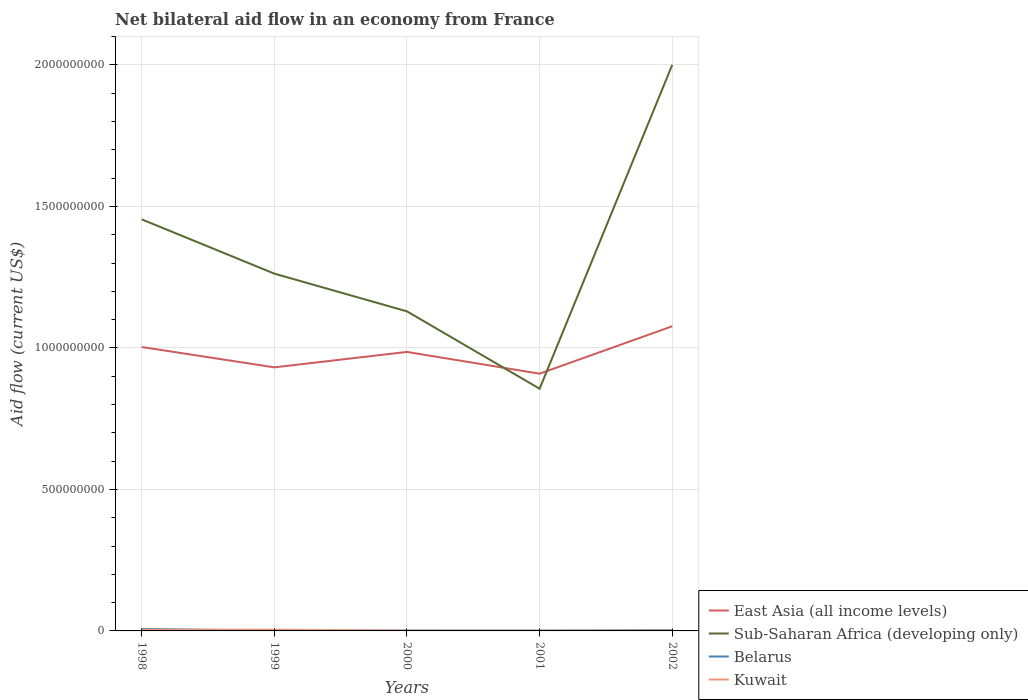Is the number of lines equal to the number of legend labels?
Your answer should be very brief. Yes. Across all years, what is the maximum net bilateral aid flow in Kuwait?
Offer a very short reply. 1.01e+06. What is the total net bilateral aid flow in East Asia (all income levels) in the graph?
Give a very brief answer. -7.34e+07. What is the difference between the highest and the second highest net bilateral aid flow in Sub-Saharan Africa (developing only)?
Your response must be concise. 1.14e+09. What is the difference between the highest and the lowest net bilateral aid flow in Kuwait?
Your answer should be compact. 2. How many years are there in the graph?
Your answer should be compact. 5. Are the values on the major ticks of Y-axis written in scientific E-notation?
Your answer should be very brief. No. Does the graph contain grids?
Ensure brevity in your answer.  Yes. How many legend labels are there?
Offer a terse response. 4. How are the legend labels stacked?
Provide a succinct answer. Vertical. What is the title of the graph?
Ensure brevity in your answer.  Net bilateral aid flow in an economy from France. Does "Upper middle income" appear as one of the legend labels in the graph?
Offer a very short reply. No. What is the label or title of the X-axis?
Keep it short and to the point. Years. What is the label or title of the Y-axis?
Your response must be concise. Aid flow (current US$). What is the Aid flow (current US$) of East Asia (all income levels) in 1998?
Your response must be concise. 1.00e+09. What is the Aid flow (current US$) of Sub-Saharan Africa (developing only) in 1998?
Make the answer very short. 1.45e+09. What is the Aid flow (current US$) of Belarus in 1998?
Provide a short and direct response. 6.89e+06. What is the Aid flow (current US$) of Kuwait in 1998?
Make the answer very short. 3.95e+06. What is the Aid flow (current US$) of East Asia (all income levels) in 1999?
Your answer should be compact. 9.31e+08. What is the Aid flow (current US$) of Sub-Saharan Africa (developing only) in 1999?
Give a very brief answer. 1.26e+09. What is the Aid flow (current US$) of Belarus in 1999?
Provide a short and direct response. 1.30e+06. What is the Aid flow (current US$) in Kuwait in 1999?
Provide a succinct answer. 4.50e+06. What is the Aid flow (current US$) of East Asia (all income levels) in 2000?
Provide a short and direct response. 9.86e+08. What is the Aid flow (current US$) of Sub-Saharan Africa (developing only) in 2000?
Make the answer very short. 1.13e+09. What is the Aid flow (current US$) of Belarus in 2000?
Give a very brief answer. 1.20e+06. What is the Aid flow (current US$) of Kuwait in 2000?
Give a very brief answer. 1.04e+06. What is the Aid flow (current US$) in East Asia (all income levels) in 2001?
Give a very brief answer. 9.09e+08. What is the Aid flow (current US$) in Sub-Saharan Africa (developing only) in 2001?
Provide a short and direct response. 8.56e+08. What is the Aid flow (current US$) of Belarus in 2001?
Offer a terse response. 1.13e+06. What is the Aid flow (current US$) of Kuwait in 2001?
Give a very brief answer. 1.01e+06. What is the Aid flow (current US$) in East Asia (all income levels) in 2002?
Make the answer very short. 1.08e+09. What is the Aid flow (current US$) of Sub-Saharan Africa (developing only) in 2002?
Ensure brevity in your answer.  2.00e+09. What is the Aid flow (current US$) of Belarus in 2002?
Ensure brevity in your answer.  2.82e+06. What is the Aid flow (current US$) of Kuwait in 2002?
Provide a short and direct response. 1.40e+06. Across all years, what is the maximum Aid flow (current US$) of East Asia (all income levels)?
Keep it short and to the point. 1.08e+09. Across all years, what is the maximum Aid flow (current US$) in Sub-Saharan Africa (developing only)?
Provide a succinct answer. 2.00e+09. Across all years, what is the maximum Aid flow (current US$) of Belarus?
Your answer should be very brief. 6.89e+06. Across all years, what is the maximum Aid flow (current US$) in Kuwait?
Offer a very short reply. 4.50e+06. Across all years, what is the minimum Aid flow (current US$) of East Asia (all income levels)?
Offer a terse response. 9.09e+08. Across all years, what is the minimum Aid flow (current US$) of Sub-Saharan Africa (developing only)?
Keep it short and to the point. 8.56e+08. Across all years, what is the minimum Aid flow (current US$) of Belarus?
Ensure brevity in your answer.  1.13e+06. Across all years, what is the minimum Aid flow (current US$) in Kuwait?
Ensure brevity in your answer.  1.01e+06. What is the total Aid flow (current US$) of East Asia (all income levels) in the graph?
Your response must be concise. 4.91e+09. What is the total Aid flow (current US$) of Sub-Saharan Africa (developing only) in the graph?
Provide a short and direct response. 6.70e+09. What is the total Aid flow (current US$) of Belarus in the graph?
Ensure brevity in your answer.  1.33e+07. What is the total Aid flow (current US$) of Kuwait in the graph?
Ensure brevity in your answer.  1.19e+07. What is the difference between the Aid flow (current US$) in East Asia (all income levels) in 1998 and that in 1999?
Provide a succinct answer. 7.18e+07. What is the difference between the Aid flow (current US$) in Sub-Saharan Africa (developing only) in 1998 and that in 1999?
Keep it short and to the point. 1.92e+08. What is the difference between the Aid flow (current US$) in Belarus in 1998 and that in 1999?
Give a very brief answer. 5.59e+06. What is the difference between the Aid flow (current US$) in Kuwait in 1998 and that in 1999?
Keep it short and to the point. -5.50e+05. What is the difference between the Aid flow (current US$) in East Asia (all income levels) in 1998 and that in 2000?
Make the answer very short. 1.73e+07. What is the difference between the Aid flow (current US$) in Sub-Saharan Africa (developing only) in 1998 and that in 2000?
Keep it short and to the point. 3.25e+08. What is the difference between the Aid flow (current US$) of Belarus in 1998 and that in 2000?
Provide a succinct answer. 5.69e+06. What is the difference between the Aid flow (current US$) of Kuwait in 1998 and that in 2000?
Provide a short and direct response. 2.91e+06. What is the difference between the Aid flow (current US$) of East Asia (all income levels) in 1998 and that in 2001?
Ensure brevity in your answer.  9.42e+07. What is the difference between the Aid flow (current US$) of Sub-Saharan Africa (developing only) in 1998 and that in 2001?
Ensure brevity in your answer.  5.98e+08. What is the difference between the Aid flow (current US$) in Belarus in 1998 and that in 2001?
Your answer should be very brief. 5.76e+06. What is the difference between the Aid flow (current US$) in Kuwait in 1998 and that in 2001?
Your answer should be very brief. 2.94e+06. What is the difference between the Aid flow (current US$) in East Asia (all income levels) in 1998 and that in 2002?
Provide a short and direct response. -7.34e+07. What is the difference between the Aid flow (current US$) in Sub-Saharan Africa (developing only) in 1998 and that in 2002?
Keep it short and to the point. -5.46e+08. What is the difference between the Aid flow (current US$) of Belarus in 1998 and that in 2002?
Keep it short and to the point. 4.07e+06. What is the difference between the Aid flow (current US$) in Kuwait in 1998 and that in 2002?
Keep it short and to the point. 2.55e+06. What is the difference between the Aid flow (current US$) of East Asia (all income levels) in 1999 and that in 2000?
Offer a very short reply. -5.45e+07. What is the difference between the Aid flow (current US$) in Sub-Saharan Africa (developing only) in 1999 and that in 2000?
Give a very brief answer. 1.33e+08. What is the difference between the Aid flow (current US$) of Kuwait in 1999 and that in 2000?
Your answer should be very brief. 3.46e+06. What is the difference between the Aid flow (current US$) of East Asia (all income levels) in 1999 and that in 2001?
Give a very brief answer. 2.24e+07. What is the difference between the Aid flow (current US$) in Sub-Saharan Africa (developing only) in 1999 and that in 2001?
Your answer should be compact. 4.07e+08. What is the difference between the Aid flow (current US$) in Belarus in 1999 and that in 2001?
Offer a terse response. 1.70e+05. What is the difference between the Aid flow (current US$) in Kuwait in 1999 and that in 2001?
Your response must be concise. 3.49e+06. What is the difference between the Aid flow (current US$) of East Asia (all income levels) in 1999 and that in 2002?
Your response must be concise. -1.45e+08. What is the difference between the Aid flow (current US$) in Sub-Saharan Africa (developing only) in 1999 and that in 2002?
Keep it short and to the point. -7.38e+08. What is the difference between the Aid flow (current US$) of Belarus in 1999 and that in 2002?
Ensure brevity in your answer.  -1.52e+06. What is the difference between the Aid flow (current US$) of Kuwait in 1999 and that in 2002?
Provide a short and direct response. 3.10e+06. What is the difference between the Aid flow (current US$) in East Asia (all income levels) in 2000 and that in 2001?
Your answer should be compact. 7.69e+07. What is the difference between the Aid flow (current US$) of Sub-Saharan Africa (developing only) in 2000 and that in 2001?
Provide a short and direct response. 2.73e+08. What is the difference between the Aid flow (current US$) in Belarus in 2000 and that in 2001?
Ensure brevity in your answer.  7.00e+04. What is the difference between the Aid flow (current US$) in Kuwait in 2000 and that in 2001?
Give a very brief answer. 3.00e+04. What is the difference between the Aid flow (current US$) in East Asia (all income levels) in 2000 and that in 2002?
Offer a terse response. -9.07e+07. What is the difference between the Aid flow (current US$) of Sub-Saharan Africa (developing only) in 2000 and that in 2002?
Ensure brevity in your answer.  -8.71e+08. What is the difference between the Aid flow (current US$) in Belarus in 2000 and that in 2002?
Your answer should be very brief. -1.62e+06. What is the difference between the Aid flow (current US$) of Kuwait in 2000 and that in 2002?
Provide a succinct answer. -3.60e+05. What is the difference between the Aid flow (current US$) in East Asia (all income levels) in 2001 and that in 2002?
Give a very brief answer. -1.68e+08. What is the difference between the Aid flow (current US$) in Sub-Saharan Africa (developing only) in 2001 and that in 2002?
Provide a succinct answer. -1.14e+09. What is the difference between the Aid flow (current US$) in Belarus in 2001 and that in 2002?
Your answer should be compact. -1.69e+06. What is the difference between the Aid flow (current US$) in Kuwait in 2001 and that in 2002?
Your answer should be very brief. -3.90e+05. What is the difference between the Aid flow (current US$) of East Asia (all income levels) in 1998 and the Aid flow (current US$) of Sub-Saharan Africa (developing only) in 1999?
Offer a very short reply. -2.59e+08. What is the difference between the Aid flow (current US$) of East Asia (all income levels) in 1998 and the Aid flow (current US$) of Belarus in 1999?
Make the answer very short. 1.00e+09. What is the difference between the Aid flow (current US$) in East Asia (all income levels) in 1998 and the Aid flow (current US$) in Kuwait in 1999?
Your answer should be very brief. 9.99e+08. What is the difference between the Aid flow (current US$) in Sub-Saharan Africa (developing only) in 1998 and the Aid flow (current US$) in Belarus in 1999?
Provide a short and direct response. 1.45e+09. What is the difference between the Aid flow (current US$) in Sub-Saharan Africa (developing only) in 1998 and the Aid flow (current US$) in Kuwait in 1999?
Ensure brevity in your answer.  1.45e+09. What is the difference between the Aid flow (current US$) in Belarus in 1998 and the Aid flow (current US$) in Kuwait in 1999?
Ensure brevity in your answer.  2.39e+06. What is the difference between the Aid flow (current US$) in East Asia (all income levels) in 1998 and the Aid flow (current US$) in Sub-Saharan Africa (developing only) in 2000?
Your answer should be very brief. -1.26e+08. What is the difference between the Aid flow (current US$) of East Asia (all income levels) in 1998 and the Aid flow (current US$) of Belarus in 2000?
Keep it short and to the point. 1.00e+09. What is the difference between the Aid flow (current US$) in East Asia (all income levels) in 1998 and the Aid flow (current US$) in Kuwait in 2000?
Your answer should be very brief. 1.00e+09. What is the difference between the Aid flow (current US$) in Sub-Saharan Africa (developing only) in 1998 and the Aid flow (current US$) in Belarus in 2000?
Make the answer very short. 1.45e+09. What is the difference between the Aid flow (current US$) in Sub-Saharan Africa (developing only) in 1998 and the Aid flow (current US$) in Kuwait in 2000?
Your answer should be compact. 1.45e+09. What is the difference between the Aid flow (current US$) of Belarus in 1998 and the Aid flow (current US$) of Kuwait in 2000?
Keep it short and to the point. 5.85e+06. What is the difference between the Aid flow (current US$) of East Asia (all income levels) in 1998 and the Aid flow (current US$) of Sub-Saharan Africa (developing only) in 2001?
Your answer should be compact. 1.47e+08. What is the difference between the Aid flow (current US$) in East Asia (all income levels) in 1998 and the Aid flow (current US$) in Belarus in 2001?
Give a very brief answer. 1.00e+09. What is the difference between the Aid flow (current US$) of East Asia (all income levels) in 1998 and the Aid flow (current US$) of Kuwait in 2001?
Give a very brief answer. 1.00e+09. What is the difference between the Aid flow (current US$) of Sub-Saharan Africa (developing only) in 1998 and the Aid flow (current US$) of Belarus in 2001?
Give a very brief answer. 1.45e+09. What is the difference between the Aid flow (current US$) in Sub-Saharan Africa (developing only) in 1998 and the Aid flow (current US$) in Kuwait in 2001?
Your answer should be very brief. 1.45e+09. What is the difference between the Aid flow (current US$) of Belarus in 1998 and the Aid flow (current US$) of Kuwait in 2001?
Provide a succinct answer. 5.88e+06. What is the difference between the Aid flow (current US$) in East Asia (all income levels) in 1998 and the Aid flow (current US$) in Sub-Saharan Africa (developing only) in 2002?
Provide a short and direct response. -9.97e+08. What is the difference between the Aid flow (current US$) of East Asia (all income levels) in 1998 and the Aid flow (current US$) of Belarus in 2002?
Give a very brief answer. 1.00e+09. What is the difference between the Aid flow (current US$) of East Asia (all income levels) in 1998 and the Aid flow (current US$) of Kuwait in 2002?
Provide a short and direct response. 1.00e+09. What is the difference between the Aid flow (current US$) of Sub-Saharan Africa (developing only) in 1998 and the Aid flow (current US$) of Belarus in 2002?
Make the answer very short. 1.45e+09. What is the difference between the Aid flow (current US$) of Sub-Saharan Africa (developing only) in 1998 and the Aid flow (current US$) of Kuwait in 2002?
Keep it short and to the point. 1.45e+09. What is the difference between the Aid flow (current US$) in Belarus in 1998 and the Aid flow (current US$) in Kuwait in 2002?
Your answer should be very brief. 5.49e+06. What is the difference between the Aid flow (current US$) of East Asia (all income levels) in 1999 and the Aid flow (current US$) of Sub-Saharan Africa (developing only) in 2000?
Your answer should be very brief. -1.98e+08. What is the difference between the Aid flow (current US$) in East Asia (all income levels) in 1999 and the Aid flow (current US$) in Belarus in 2000?
Provide a succinct answer. 9.30e+08. What is the difference between the Aid flow (current US$) in East Asia (all income levels) in 1999 and the Aid flow (current US$) in Kuwait in 2000?
Give a very brief answer. 9.30e+08. What is the difference between the Aid flow (current US$) of Sub-Saharan Africa (developing only) in 1999 and the Aid flow (current US$) of Belarus in 2000?
Your response must be concise. 1.26e+09. What is the difference between the Aid flow (current US$) of Sub-Saharan Africa (developing only) in 1999 and the Aid flow (current US$) of Kuwait in 2000?
Your answer should be compact. 1.26e+09. What is the difference between the Aid flow (current US$) of Belarus in 1999 and the Aid flow (current US$) of Kuwait in 2000?
Offer a terse response. 2.60e+05. What is the difference between the Aid flow (current US$) of East Asia (all income levels) in 1999 and the Aid flow (current US$) of Sub-Saharan Africa (developing only) in 2001?
Give a very brief answer. 7.55e+07. What is the difference between the Aid flow (current US$) of East Asia (all income levels) in 1999 and the Aid flow (current US$) of Belarus in 2001?
Provide a succinct answer. 9.30e+08. What is the difference between the Aid flow (current US$) in East Asia (all income levels) in 1999 and the Aid flow (current US$) in Kuwait in 2001?
Offer a terse response. 9.30e+08. What is the difference between the Aid flow (current US$) of Sub-Saharan Africa (developing only) in 1999 and the Aid flow (current US$) of Belarus in 2001?
Provide a short and direct response. 1.26e+09. What is the difference between the Aid flow (current US$) of Sub-Saharan Africa (developing only) in 1999 and the Aid flow (current US$) of Kuwait in 2001?
Ensure brevity in your answer.  1.26e+09. What is the difference between the Aid flow (current US$) of East Asia (all income levels) in 1999 and the Aid flow (current US$) of Sub-Saharan Africa (developing only) in 2002?
Offer a very short reply. -1.07e+09. What is the difference between the Aid flow (current US$) in East Asia (all income levels) in 1999 and the Aid flow (current US$) in Belarus in 2002?
Give a very brief answer. 9.28e+08. What is the difference between the Aid flow (current US$) of East Asia (all income levels) in 1999 and the Aid flow (current US$) of Kuwait in 2002?
Offer a very short reply. 9.30e+08. What is the difference between the Aid flow (current US$) in Sub-Saharan Africa (developing only) in 1999 and the Aid flow (current US$) in Belarus in 2002?
Ensure brevity in your answer.  1.26e+09. What is the difference between the Aid flow (current US$) in Sub-Saharan Africa (developing only) in 1999 and the Aid flow (current US$) in Kuwait in 2002?
Offer a terse response. 1.26e+09. What is the difference between the Aid flow (current US$) in Belarus in 1999 and the Aid flow (current US$) in Kuwait in 2002?
Make the answer very short. -1.00e+05. What is the difference between the Aid flow (current US$) in East Asia (all income levels) in 2000 and the Aid flow (current US$) in Sub-Saharan Africa (developing only) in 2001?
Your answer should be compact. 1.30e+08. What is the difference between the Aid flow (current US$) of East Asia (all income levels) in 2000 and the Aid flow (current US$) of Belarus in 2001?
Keep it short and to the point. 9.85e+08. What is the difference between the Aid flow (current US$) of East Asia (all income levels) in 2000 and the Aid flow (current US$) of Kuwait in 2001?
Ensure brevity in your answer.  9.85e+08. What is the difference between the Aid flow (current US$) in Sub-Saharan Africa (developing only) in 2000 and the Aid flow (current US$) in Belarus in 2001?
Make the answer very short. 1.13e+09. What is the difference between the Aid flow (current US$) in Sub-Saharan Africa (developing only) in 2000 and the Aid flow (current US$) in Kuwait in 2001?
Ensure brevity in your answer.  1.13e+09. What is the difference between the Aid flow (current US$) in Belarus in 2000 and the Aid flow (current US$) in Kuwait in 2001?
Ensure brevity in your answer.  1.90e+05. What is the difference between the Aid flow (current US$) of East Asia (all income levels) in 2000 and the Aid flow (current US$) of Sub-Saharan Africa (developing only) in 2002?
Offer a terse response. -1.01e+09. What is the difference between the Aid flow (current US$) in East Asia (all income levels) in 2000 and the Aid flow (current US$) in Belarus in 2002?
Offer a very short reply. 9.83e+08. What is the difference between the Aid flow (current US$) of East Asia (all income levels) in 2000 and the Aid flow (current US$) of Kuwait in 2002?
Give a very brief answer. 9.84e+08. What is the difference between the Aid flow (current US$) of Sub-Saharan Africa (developing only) in 2000 and the Aid flow (current US$) of Belarus in 2002?
Your answer should be compact. 1.13e+09. What is the difference between the Aid flow (current US$) of Sub-Saharan Africa (developing only) in 2000 and the Aid flow (current US$) of Kuwait in 2002?
Your answer should be very brief. 1.13e+09. What is the difference between the Aid flow (current US$) in Belarus in 2000 and the Aid flow (current US$) in Kuwait in 2002?
Your response must be concise. -2.00e+05. What is the difference between the Aid flow (current US$) of East Asia (all income levels) in 2001 and the Aid flow (current US$) of Sub-Saharan Africa (developing only) in 2002?
Your response must be concise. -1.09e+09. What is the difference between the Aid flow (current US$) in East Asia (all income levels) in 2001 and the Aid flow (current US$) in Belarus in 2002?
Offer a very short reply. 9.06e+08. What is the difference between the Aid flow (current US$) in East Asia (all income levels) in 2001 and the Aid flow (current US$) in Kuwait in 2002?
Give a very brief answer. 9.08e+08. What is the difference between the Aid flow (current US$) of Sub-Saharan Africa (developing only) in 2001 and the Aid flow (current US$) of Belarus in 2002?
Provide a short and direct response. 8.53e+08. What is the difference between the Aid flow (current US$) of Sub-Saharan Africa (developing only) in 2001 and the Aid flow (current US$) of Kuwait in 2002?
Offer a very short reply. 8.54e+08. What is the average Aid flow (current US$) in East Asia (all income levels) per year?
Offer a very short reply. 9.81e+08. What is the average Aid flow (current US$) of Sub-Saharan Africa (developing only) per year?
Offer a very short reply. 1.34e+09. What is the average Aid flow (current US$) in Belarus per year?
Give a very brief answer. 2.67e+06. What is the average Aid flow (current US$) in Kuwait per year?
Offer a very short reply. 2.38e+06. In the year 1998, what is the difference between the Aid flow (current US$) of East Asia (all income levels) and Aid flow (current US$) of Sub-Saharan Africa (developing only)?
Offer a very short reply. -4.51e+08. In the year 1998, what is the difference between the Aid flow (current US$) in East Asia (all income levels) and Aid flow (current US$) in Belarus?
Ensure brevity in your answer.  9.96e+08. In the year 1998, what is the difference between the Aid flow (current US$) of East Asia (all income levels) and Aid flow (current US$) of Kuwait?
Your answer should be very brief. 9.99e+08. In the year 1998, what is the difference between the Aid flow (current US$) of Sub-Saharan Africa (developing only) and Aid flow (current US$) of Belarus?
Give a very brief answer. 1.45e+09. In the year 1998, what is the difference between the Aid flow (current US$) in Sub-Saharan Africa (developing only) and Aid flow (current US$) in Kuwait?
Your response must be concise. 1.45e+09. In the year 1998, what is the difference between the Aid flow (current US$) of Belarus and Aid flow (current US$) of Kuwait?
Your answer should be compact. 2.94e+06. In the year 1999, what is the difference between the Aid flow (current US$) in East Asia (all income levels) and Aid flow (current US$) in Sub-Saharan Africa (developing only)?
Give a very brief answer. -3.31e+08. In the year 1999, what is the difference between the Aid flow (current US$) of East Asia (all income levels) and Aid flow (current US$) of Belarus?
Give a very brief answer. 9.30e+08. In the year 1999, what is the difference between the Aid flow (current US$) in East Asia (all income levels) and Aid flow (current US$) in Kuwait?
Your answer should be very brief. 9.27e+08. In the year 1999, what is the difference between the Aid flow (current US$) in Sub-Saharan Africa (developing only) and Aid flow (current US$) in Belarus?
Your response must be concise. 1.26e+09. In the year 1999, what is the difference between the Aid flow (current US$) of Sub-Saharan Africa (developing only) and Aid flow (current US$) of Kuwait?
Ensure brevity in your answer.  1.26e+09. In the year 1999, what is the difference between the Aid flow (current US$) of Belarus and Aid flow (current US$) of Kuwait?
Ensure brevity in your answer.  -3.20e+06. In the year 2000, what is the difference between the Aid flow (current US$) of East Asia (all income levels) and Aid flow (current US$) of Sub-Saharan Africa (developing only)?
Make the answer very short. -1.43e+08. In the year 2000, what is the difference between the Aid flow (current US$) in East Asia (all income levels) and Aid flow (current US$) in Belarus?
Make the answer very short. 9.85e+08. In the year 2000, what is the difference between the Aid flow (current US$) in East Asia (all income levels) and Aid flow (current US$) in Kuwait?
Ensure brevity in your answer.  9.85e+08. In the year 2000, what is the difference between the Aid flow (current US$) in Sub-Saharan Africa (developing only) and Aid flow (current US$) in Belarus?
Offer a very short reply. 1.13e+09. In the year 2000, what is the difference between the Aid flow (current US$) of Sub-Saharan Africa (developing only) and Aid flow (current US$) of Kuwait?
Your answer should be very brief. 1.13e+09. In the year 2000, what is the difference between the Aid flow (current US$) in Belarus and Aid flow (current US$) in Kuwait?
Ensure brevity in your answer.  1.60e+05. In the year 2001, what is the difference between the Aid flow (current US$) of East Asia (all income levels) and Aid flow (current US$) of Sub-Saharan Africa (developing only)?
Offer a terse response. 5.32e+07. In the year 2001, what is the difference between the Aid flow (current US$) in East Asia (all income levels) and Aid flow (current US$) in Belarus?
Offer a very short reply. 9.08e+08. In the year 2001, what is the difference between the Aid flow (current US$) of East Asia (all income levels) and Aid flow (current US$) of Kuwait?
Your answer should be compact. 9.08e+08. In the year 2001, what is the difference between the Aid flow (current US$) in Sub-Saharan Africa (developing only) and Aid flow (current US$) in Belarus?
Give a very brief answer. 8.55e+08. In the year 2001, what is the difference between the Aid flow (current US$) of Sub-Saharan Africa (developing only) and Aid flow (current US$) of Kuwait?
Offer a very short reply. 8.55e+08. In the year 2002, what is the difference between the Aid flow (current US$) in East Asia (all income levels) and Aid flow (current US$) in Sub-Saharan Africa (developing only)?
Offer a very short reply. -9.24e+08. In the year 2002, what is the difference between the Aid flow (current US$) in East Asia (all income levels) and Aid flow (current US$) in Belarus?
Your answer should be compact. 1.07e+09. In the year 2002, what is the difference between the Aid flow (current US$) in East Asia (all income levels) and Aid flow (current US$) in Kuwait?
Offer a very short reply. 1.08e+09. In the year 2002, what is the difference between the Aid flow (current US$) in Sub-Saharan Africa (developing only) and Aid flow (current US$) in Belarus?
Provide a short and direct response. 2.00e+09. In the year 2002, what is the difference between the Aid flow (current US$) of Sub-Saharan Africa (developing only) and Aid flow (current US$) of Kuwait?
Keep it short and to the point. 2.00e+09. In the year 2002, what is the difference between the Aid flow (current US$) of Belarus and Aid flow (current US$) of Kuwait?
Ensure brevity in your answer.  1.42e+06. What is the ratio of the Aid flow (current US$) of East Asia (all income levels) in 1998 to that in 1999?
Your answer should be compact. 1.08. What is the ratio of the Aid flow (current US$) in Sub-Saharan Africa (developing only) in 1998 to that in 1999?
Keep it short and to the point. 1.15. What is the ratio of the Aid flow (current US$) in Belarus in 1998 to that in 1999?
Offer a very short reply. 5.3. What is the ratio of the Aid flow (current US$) of Kuwait in 1998 to that in 1999?
Make the answer very short. 0.88. What is the ratio of the Aid flow (current US$) in East Asia (all income levels) in 1998 to that in 2000?
Keep it short and to the point. 1.02. What is the ratio of the Aid flow (current US$) in Sub-Saharan Africa (developing only) in 1998 to that in 2000?
Your response must be concise. 1.29. What is the ratio of the Aid flow (current US$) of Belarus in 1998 to that in 2000?
Make the answer very short. 5.74. What is the ratio of the Aid flow (current US$) in Kuwait in 1998 to that in 2000?
Your response must be concise. 3.8. What is the ratio of the Aid flow (current US$) of East Asia (all income levels) in 1998 to that in 2001?
Provide a short and direct response. 1.1. What is the ratio of the Aid flow (current US$) in Sub-Saharan Africa (developing only) in 1998 to that in 2001?
Offer a very short reply. 1.7. What is the ratio of the Aid flow (current US$) of Belarus in 1998 to that in 2001?
Give a very brief answer. 6.1. What is the ratio of the Aid flow (current US$) in Kuwait in 1998 to that in 2001?
Ensure brevity in your answer.  3.91. What is the ratio of the Aid flow (current US$) of East Asia (all income levels) in 1998 to that in 2002?
Offer a terse response. 0.93. What is the ratio of the Aid flow (current US$) of Sub-Saharan Africa (developing only) in 1998 to that in 2002?
Offer a very short reply. 0.73. What is the ratio of the Aid flow (current US$) in Belarus in 1998 to that in 2002?
Provide a succinct answer. 2.44. What is the ratio of the Aid flow (current US$) in Kuwait in 1998 to that in 2002?
Ensure brevity in your answer.  2.82. What is the ratio of the Aid flow (current US$) in East Asia (all income levels) in 1999 to that in 2000?
Give a very brief answer. 0.94. What is the ratio of the Aid flow (current US$) in Sub-Saharan Africa (developing only) in 1999 to that in 2000?
Provide a short and direct response. 1.12. What is the ratio of the Aid flow (current US$) in Kuwait in 1999 to that in 2000?
Your answer should be very brief. 4.33. What is the ratio of the Aid flow (current US$) of East Asia (all income levels) in 1999 to that in 2001?
Keep it short and to the point. 1.02. What is the ratio of the Aid flow (current US$) in Sub-Saharan Africa (developing only) in 1999 to that in 2001?
Your answer should be compact. 1.48. What is the ratio of the Aid flow (current US$) in Belarus in 1999 to that in 2001?
Offer a terse response. 1.15. What is the ratio of the Aid flow (current US$) of Kuwait in 1999 to that in 2001?
Offer a terse response. 4.46. What is the ratio of the Aid flow (current US$) in East Asia (all income levels) in 1999 to that in 2002?
Offer a very short reply. 0.87. What is the ratio of the Aid flow (current US$) in Sub-Saharan Africa (developing only) in 1999 to that in 2002?
Your response must be concise. 0.63. What is the ratio of the Aid flow (current US$) in Belarus in 1999 to that in 2002?
Your answer should be very brief. 0.46. What is the ratio of the Aid flow (current US$) in Kuwait in 1999 to that in 2002?
Keep it short and to the point. 3.21. What is the ratio of the Aid flow (current US$) of East Asia (all income levels) in 2000 to that in 2001?
Your answer should be very brief. 1.08. What is the ratio of the Aid flow (current US$) of Sub-Saharan Africa (developing only) in 2000 to that in 2001?
Your answer should be compact. 1.32. What is the ratio of the Aid flow (current US$) in Belarus in 2000 to that in 2001?
Keep it short and to the point. 1.06. What is the ratio of the Aid flow (current US$) in Kuwait in 2000 to that in 2001?
Offer a terse response. 1.03. What is the ratio of the Aid flow (current US$) in East Asia (all income levels) in 2000 to that in 2002?
Your response must be concise. 0.92. What is the ratio of the Aid flow (current US$) of Sub-Saharan Africa (developing only) in 2000 to that in 2002?
Offer a very short reply. 0.56. What is the ratio of the Aid flow (current US$) in Belarus in 2000 to that in 2002?
Offer a very short reply. 0.43. What is the ratio of the Aid flow (current US$) in Kuwait in 2000 to that in 2002?
Ensure brevity in your answer.  0.74. What is the ratio of the Aid flow (current US$) in East Asia (all income levels) in 2001 to that in 2002?
Provide a short and direct response. 0.84. What is the ratio of the Aid flow (current US$) of Sub-Saharan Africa (developing only) in 2001 to that in 2002?
Your answer should be very brief. 0.43. What is the ratio of the Aid flow (current US$) of Belarus in 2001 to that in 2002?
Provide a succinct answer. 0.4. What is the ratio of the Aid flow (current US$) of Kuwait in 2001 to that in 2002?
Give a very brief answer. 0.72. What is the difference between the highest and the second highest Aid flow (current US$) of East Asia (all income levels)?
Your answer should be very brief. 7.34e+07. What is the difference between the highest and the second highest Aid flow (current US$) of Sub-Saharan Africa (developing only)?
Offer a very short reply. 5.46e+08. What is the difference between the highest and the second highest Aid flow (current US$) in Belarus?
Ensure brevity in your answer.  4.07e+06. What is the difference between the highest and the second highest Aid flow (current US$) of Kuwait?
Give a very brief answer. 5.50e+05. What is the difference between the highest and the lowest Aid flow (current US$) of East Asia (all income levels)?
Give a very brief answer. 1.68e+08. What is the difference between the highest and the lowest Aid flow (current US$) in Sub-Saharan Africa (developing only)?
Give a very brief answer. 1.14e+09. What is the difference between the highest and the lowest Aid flow (current US$) of Belarus?
Your response must be concise. 5.76e+06. What is the difference between the highest and the lowest Aid flow (current US$) in Kuwait?
Give a very brief answer. 3.49e+06. 